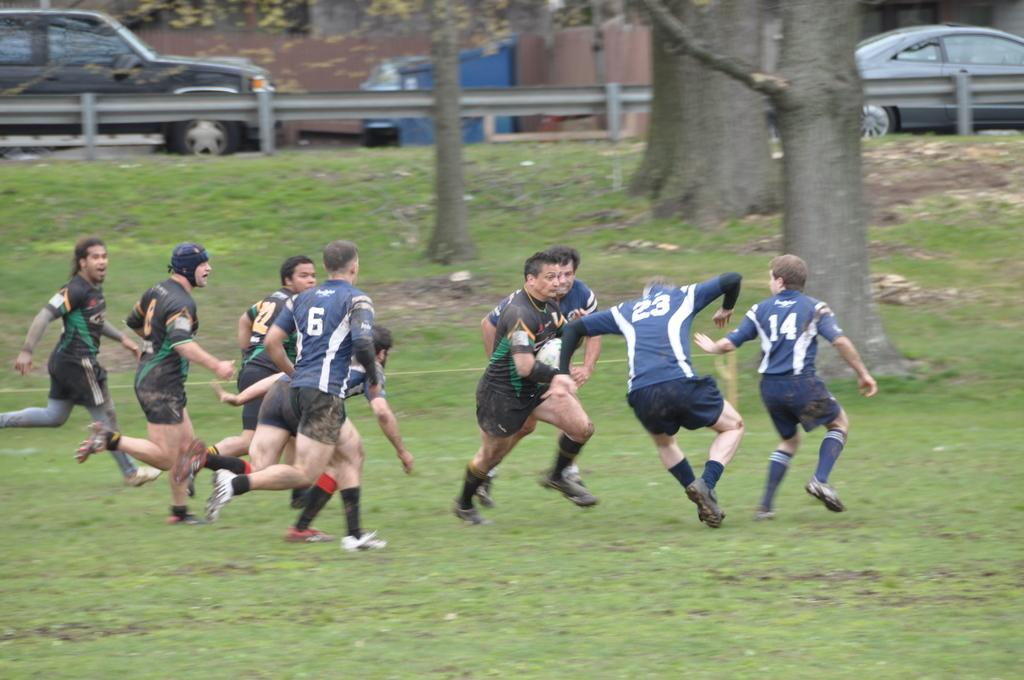What are the people in the image doing? The people in the image are running. What are the people wearing while running? The people are wearing clothes, socks, and shoes. What type of terrain can be seen in the image? There is grass visible in the image, as well as a tree trunk. What safety feature is present in the image? There is a road barrier in the image. What else can be seen in the image besides the people running? There are vehicles in the image. What type of stem can be seen growing from the tree trunk in the image? There is no stem growing from the tree trunk in the image; only the tree trunk itself is visible. What type of powder is being used by the people running in the image? There is no powder being used by the people running in the image. 